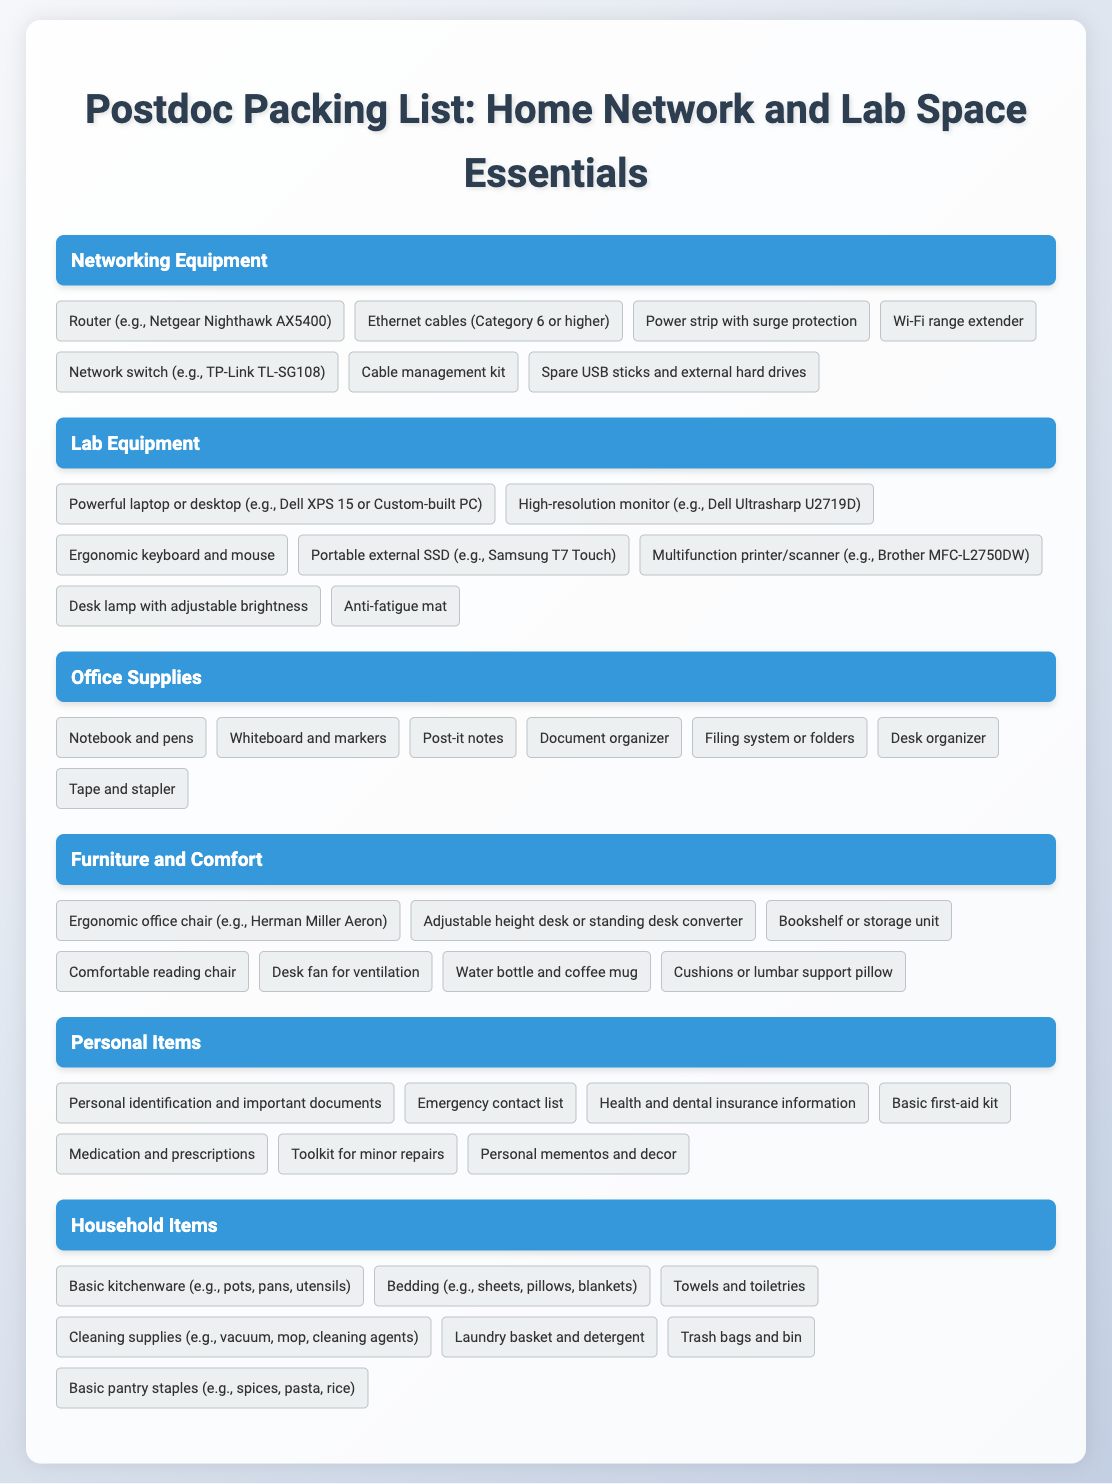What type of router is suggested? The document suggests a specific model of router, which is a Netgear Nighthawk AX5400.
Answer: Netgear Nighthawk AX5400 How many items are listed under Networking Equipment? The document lists a total of 7 items in the Networking Equipment category.
Answer: 7 What is a recommended type of chair for comfort? The document recommends an ergonomic office chair, with a specific example being the Herman Miller Aeron.
Answer: Ergonomic office chair (e.g., Herman Miller Aeron) What should you include in your basic first-aid kit? The document states that a basic first-aid kit is among the personal items to pack, but does not specify items in detail.
Answer: Basic first-aid kit Name one electronic device recommended for lab space. The document lists several lab equipment items, including a powerful laptop or desktop.
Answer: Powerful laptop or desktop Which item is suggested for managing cables? The document mentions a cable management kit as an essential item for organizing cables.
Answer: Cable management kit What is listed under Household Items? The document includes various household items, one of which is basic kitchenware such as pots, pans, and utensils.
Answer: Basic kitchenware (e.g., pots, pans, utensils) How many categories are there in the packing list? The packing list features a total of 6 distinct categories.
Answer: 6 What type of desk is recommended? The document suggests using an adjustable height desk or a standing desk converter for better ergonomics.
Answer: Adjustable height desk or standing desk converter What is included in the Office Supplies category? The document lists various office supplies, including notebooks and pens as essential items.
Answer: Notebook and pens 